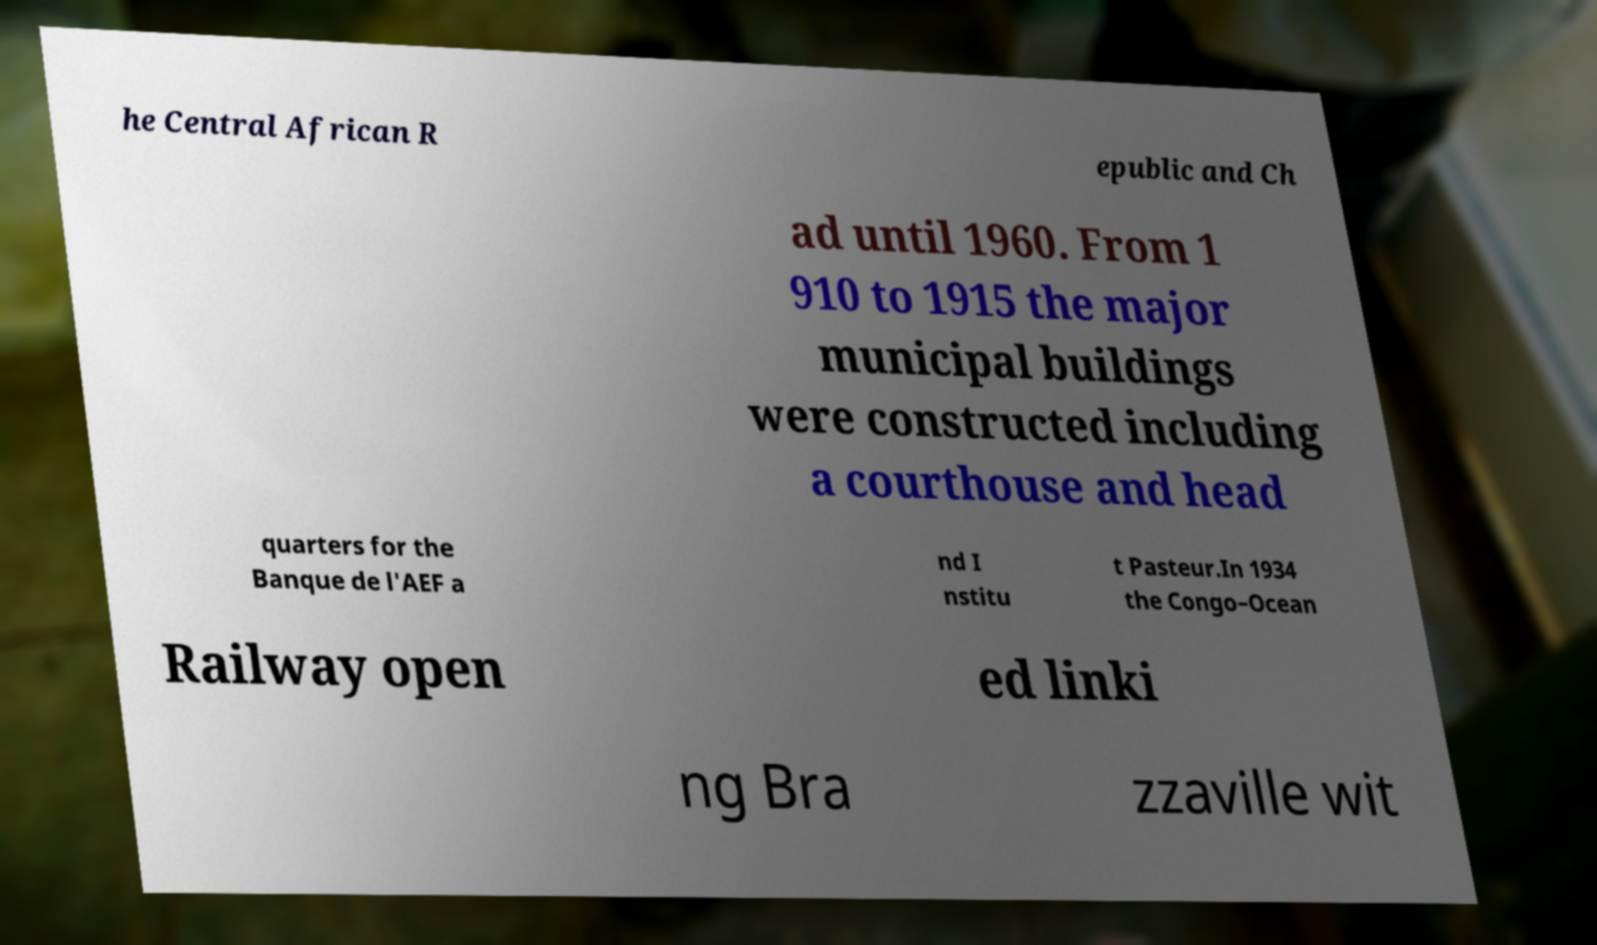Please read and relay the text visible in this image. What does it say? he Central African R epublic and Ch ad until 1960. From 1 910 to 1915 the major municipal buildings were constructed including a courthouse and head quarters for the Banque de l'AEF a nd I nstitu t Pasteur.In 1934 the Congo–Ocean Railway open ed linki ng Bra zzaville wit 